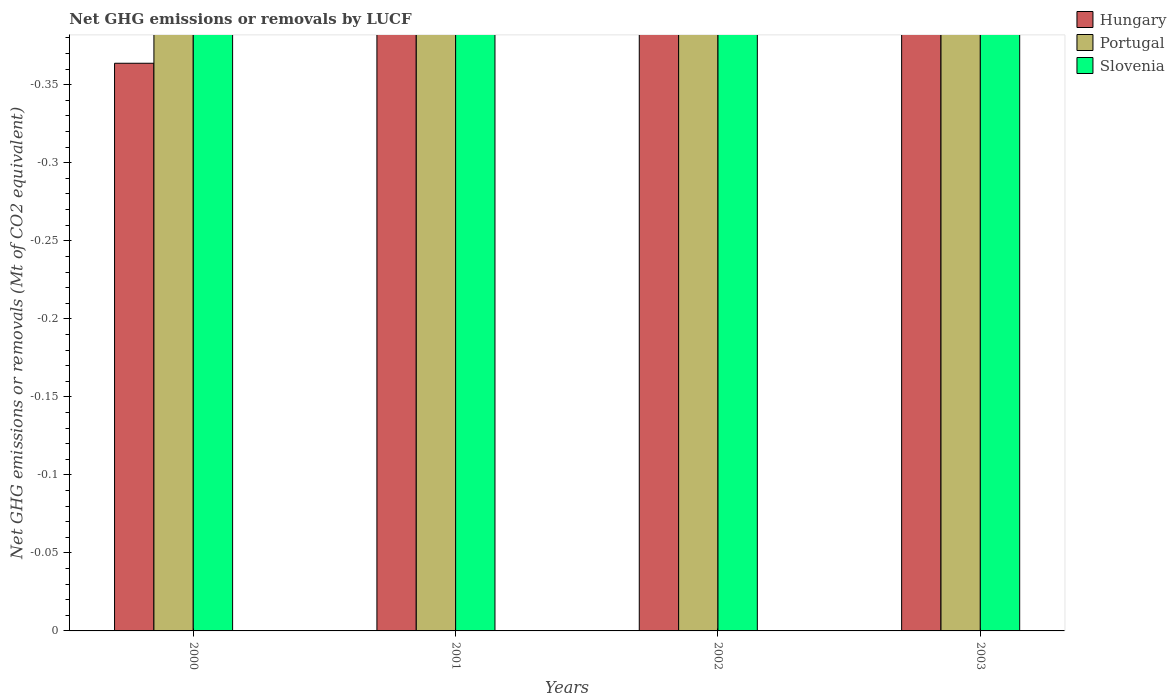How many different coloured bars are there?
Ensure brevity in your answer.  0. Are the number of bars on each tick of the X-axis equal?
Provide a succinct answer. Yes. How many bars are there on the 4th tick from the left?
Offer a very short reply. 0. In how many cases, is the number of bars for a given year not equal to the number of legend labels?
Keep it short and to the point. 4. Across all years, what is the minimum net GHG emissions or removals by LUCF in Slovenia?
Keep it short and to the point. 0. What is the total net GHG emissions or removals by LUCF in Hungary in the graph?
Your response must be concise. 0. What is the difference between the net GHG emissions or removals by LUCF in Slovenia in 2003 and the net GHG emissions or removals by LUCF in Portugal in 2002?
Make the answer very short. 0. What is the average net GHG emissions or removals by LUCF in Portugal per year?
Provide a succinct answer. 0. How many bars are there?
Ensure brevity in your answer.  0. What is the difference between two consecutive major ticks on the Y-axis?
Give a very brief answer. 0.05. Does the graph contain any zero values?
Provide a short and direct response. Yes. How many legend labels are there?
Ensure brevity in your answer.  3. What is the title of the graph?
Your answer should be very brief. Net GHG emissions or removals by LUCF. Does "Nicaragua" appear as one of the legend labels in the graph?
Provide a succinct answer. No. What is the label or title of the Y-axis?
Your answer should be compact. Net GHG emissions or removals (Mt of CO2 equivalent). What is the Net GHG emissions or removals (Mt of CO2 equivalent) of Hungary in 2000?
Make the answer very short. 0. What is the Net GHG emissions or removals (Mt of CO2 equivalent) in Slovenia in 2000?
Keep it short and to the point. 0. What is the Net GHG emissions or removals (Mt of CO2 equivalent) in Portugal in 2001?
Offer a terse response. 0. What is the Net GHG emissions or removals (Mt of CO2 equivalent) of Slovenia in 2001?
Offer a very short reply. 0. What is the Net GHG emissions or removals (Mt of CO2 equivalent) in Hungary in 2002?
Provide a succinct answer. 0. What is the Net GHG emissions or removals (Mt of CO2 equivalent) in Portugal in 2002?
Offer a very short reply. 0. What is the Net GHG emissions or removals (Mt of CO2 equivalent) of Slovenia in 2002?
Your answer should be very brief. 0. What is the Net GHG emissions or removals (Mt of CO2 equivalent) of Portugal in 2003?
Provide a short and direct response. 0. What is the average Net GHG emissions or removals (Mt of CO2 equivalent) of Hungary per year?
Your answer should be very brief. 0. What is the average Net GHG emissions or removals (Mt of CO2 equivalent) in Portugal per year?
Give a very brief answer. 0. 